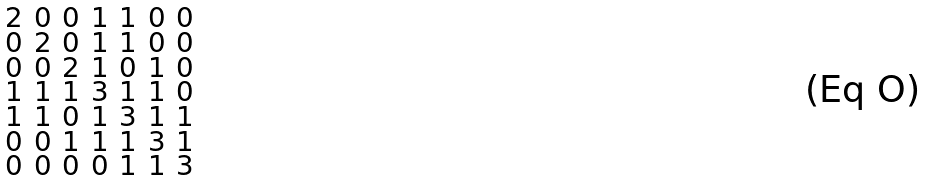Convert formula to latex. <formula><loc_0><loc_0><loc_500><loc_500>\begin{smallmatrix} 2 & 0 & 0 & 1 & 1 & 0 & 0 \\ 0 & 2 & 0 & 1 & 1 & 0 & 0 \\ 0 & 0 & 2 & 1 & 0 & 1 & 0 \\ 1 & 1 & 1 & 3 & 1 & 1 & 0 \\ 1 & 1 & 0 & 1 & 3 & 1 & 1 \\ 0 & 0 & 1 & 1 & 1 & 3 & 1 \\ 0 & 0 & 0 & 0 & 1 & 1 & 3 \end{smallmatrix}</formula> 